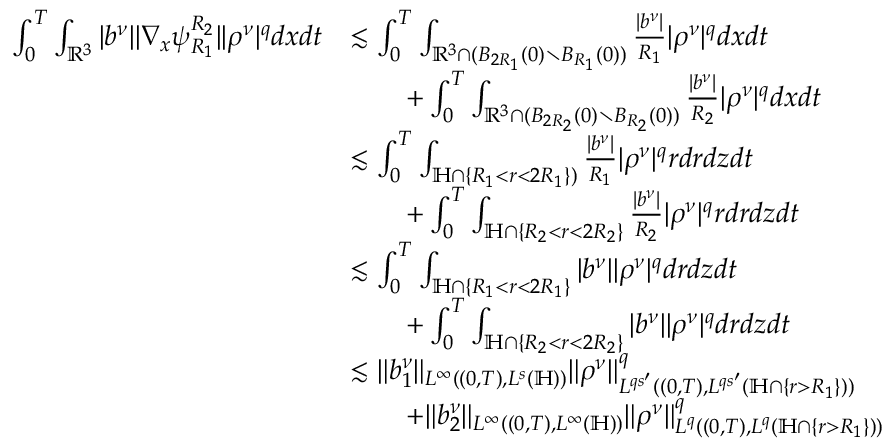Convert formula to latex. <formula><loc_0><loc_0><loc_500><loc_500>\begin{array} { r l } { \int _ { 0 } ^ { T } \int _ { \mathbb { R } ^ { 3 } } | b ^ { \nu } | | \nabla _ { x } \psi _ { R _ { 1 } } ^ { R _ { 2 } } | | \rho ^ { \nu } | ^ { q } d x d t } & { \lesssim \int _ { 0 } ^ { T } \int _ { \mathbb { R } ^ { 3 } \cap ( B _ { 2 R _ { 1 } } ( 0 ) \ B _ { R _ { 1 } } ( 0 ) ) } \frac { | b ^ { \nu } | } { R _ { 1 } } | \rho ^ { \nu } | ^ { q } d x d t } \\ & { \quad + \int _ { 0 } ^ { T } \int _ { \mathbb { R } ^ { 3 } \cap ( B _ { 2 R _ { 2 } } ( 0 ) \ B _ { R _ { 2 } } ( 0 ) ) } \frac { | b ^ { \nu } | } { R _ { 2 } } | \rho ^ { \nu } | ^ { q } d x d t } \\ & { \lesssim \int _ { 0 } ^ { T } \int _ { \mathbb { H } \cap \{ R _ { 1 } < r < 2 R _ { 1 } \} ) } \frac { | b ^ { \nu } | } { R _ { 1 } } | \rho ^ { \nu } | ^ { q } r d r d z d t } \\ & { \quad + \int _ { 0 } ^ { T } \int _ { \mathbb { H } \cap \{ R _ { 2 } < r < 2 R _ { 2 } \} } \frac { | b ^ { \nu } | } { R _ { 2 } } | \rho ^ { \nu } | ^ { q } r d r d z d t } \\ & { \lesssim \int _ { 0 } ^ { T } \int _ { \mathbb { H } \cap \{ R _ { 1 } < r < 2 R _ { 1 } \} } | b ^ { \nu } | | \rho ^ { \nu } | ^ { q } d r d z d t } \\ & { \quad + \int _ { 0 } ^ { T } \int _ { \mathbb { H } \cap \{ R _ { 2 } < r < 2 R _ { 2 } \} } | b ^ { \nu } | | \rho ^ { \nu } | ^ { q } d r d z d t } \\ & { \lesssim \| b _ { 1 } ^ { \nu } \| _ { L ^ { \infty } ( ( 0 , T ) , L ^ { s } ( \mathbb { H } ) ) } \| \rho ^ { \nu } \| _ { L ^ { q s ^ { \prime } } ( ( 0 , T ) , L ^ { q s ^ { \prime } } ( \mathbb { H } \cap \{ r > R _ { 1 } \} ) ) } ^ { q } } \\ & { \quad + \| b _ { 2 } ^ { \nu } \| _ { L ^ { \infty } ( ( 0 , T ) , L ^ { \infty } ( \mathbb { H } ) ) } \| \rho ^ { \nu } \| _ { L ^ { q } ( ( 0 , T ) , L ^ { q } ( \mathbb { H } \cap \{ r > R _ { 1 } \} ) ) } ^ { q } } \end{array}</formula> 